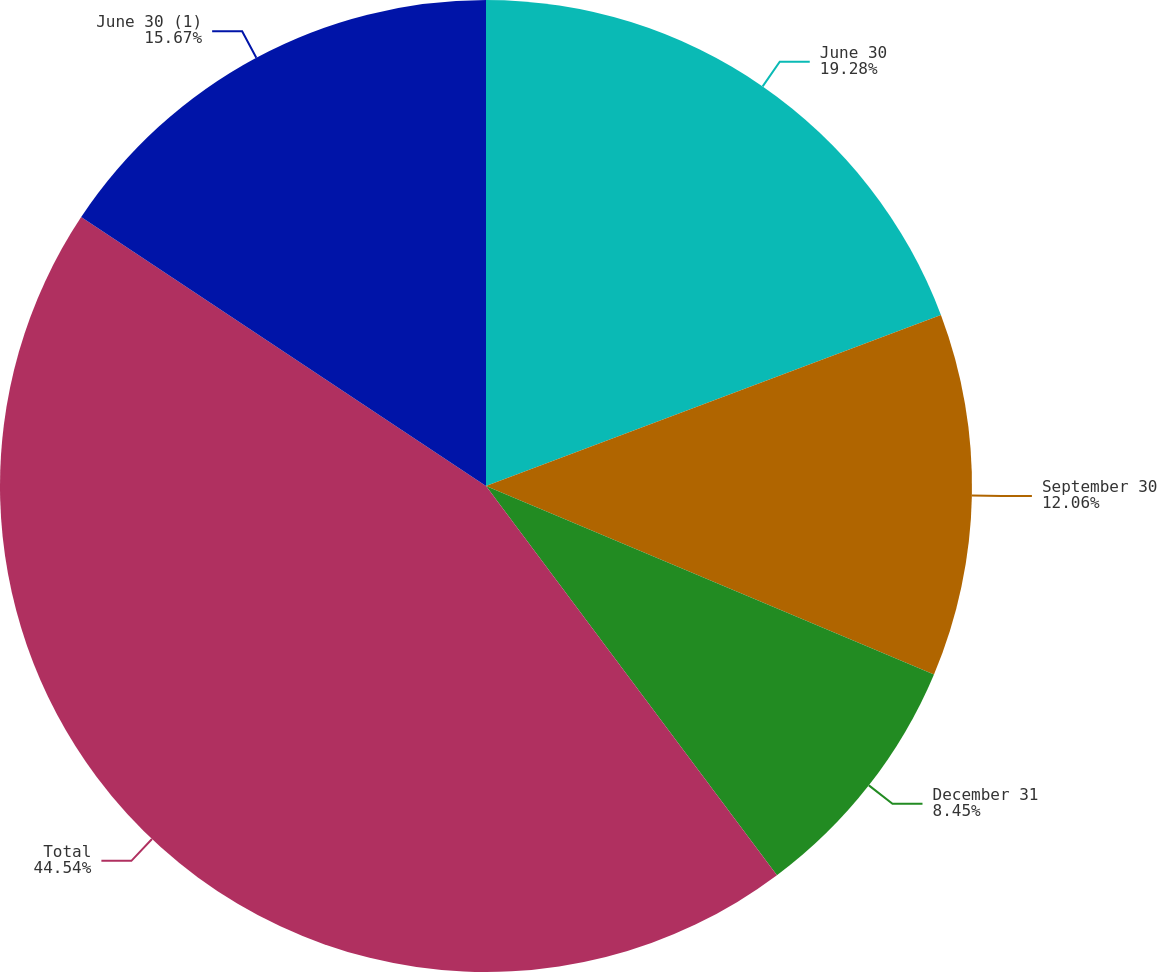Convert chart. <chart><loc_0><loc_0><loc_500><loc_500><pie_chart><fcel>June 30<fcel>September 30<fcel>December 31<fcel>Total<fcel>June 30 (1)<nl><fcel>19.28%<fcel>12.06%<fcel>8.45%<fcel>44.55%<fcel>15.67%<nl></chart> 